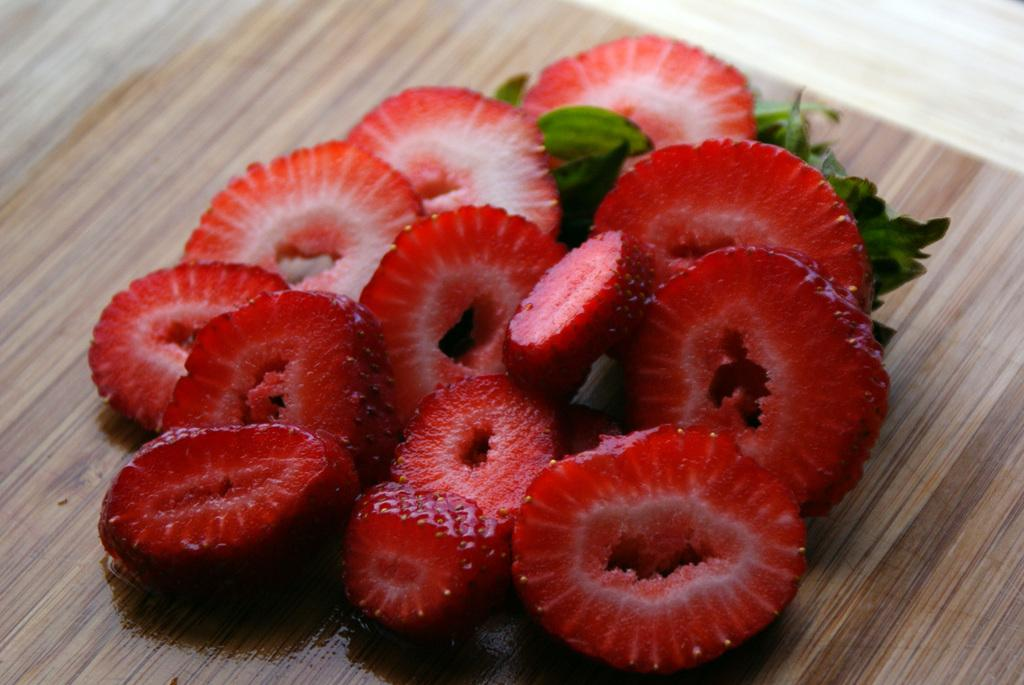What type of fruit is visible in the image? There are strawberry slices in the image. What else can be seen in the image besides the strawberry slices? There are leaves in the image. Where are the strawberry slices and leaves located? The strawberry slices and leaves are on a wooden plank. What muscle is being exercised by the strawberry slices in the image? The strawberry slices are not exercising any muscles, as they are inanimate objects. 